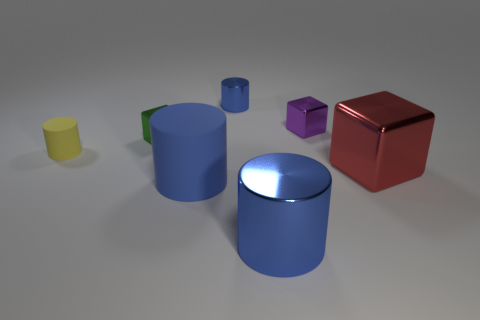Subtract all blue cylinders. How many were subtracted if there are2blue cylinders left? 1 Subtract all gray blocks. How many blue cylinders are left? 3 Add 1 tiny purple metallic objects. How many objects exist? 8 Subtract all cubes. How many objects are left? 4 Add 1 blue cylinders. How many blue cylinders are left? 4 Add 4 metal cylinders. How many metal cylinders exist? 6 Subtract 1 blue cylinders. How many objects are left? 6 Subtract all red objects. Subtract all large blue spheres. How many objects are left? 6 